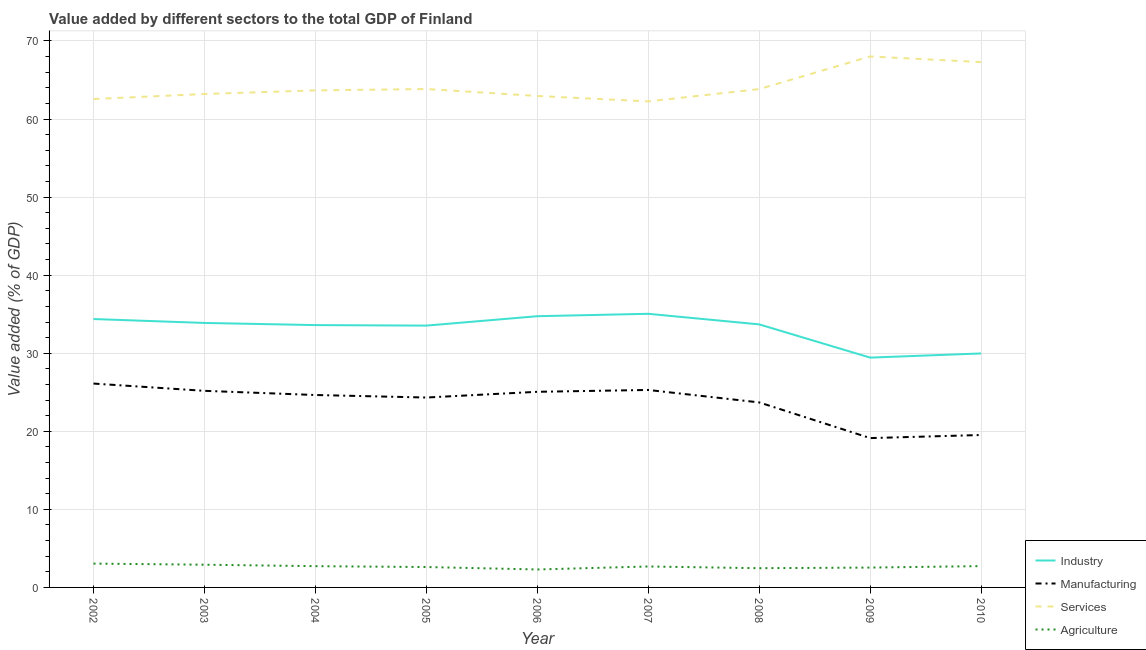How many different coloured lines are there?
Provide a succinct answer. 4. Is the number of lines equal to the number of legend labels?
Provide a short and direct response. Yes. What is the value added by industrial sector in 2004?
Offer a very short reply. 33.61. Across all years, what is the maximum value added by services sector?
Ensure brevity in your answer.  68.02. Across all years, what is the minimum value added by agricultural sector?
Offer a terse response. 2.3. In which year was the value added by manufacturing sector minimum?
Ensure brevity in your answer.  2009. What is the total value added by services sector in the graph?
Your answer should be compact. 577.67. What is the difference between the value added by agricultural sector in 2002 and that in 2010?
Your answer should be very brief. 0.32. What is the difference between the value added by services sector in 2006 and the value added by agricultural sector in 2003?
Ensure brevity in your answer.  60.05. What is the average value added by manufacturing sector per year?
Keep it short and to the point. 23.67. In the year 2006, what is the difference between the value added by services sector and value added by agricultural sector?
Offer a very short reply. 60.66. What is the ratio of the value added by services sector in 2005 to that in 2008?
Provide a short and direct response. 1. Is the value added by agricultural sector in 2005 less than that in 2006?
Your answer should be compact. No. What is the difference between the highest and the second highest value added by agricultural sector?
Offer a very short reply. 0.14. What is the difference between the highest and the lowest value added by industrial sector?
Keep it short and to the point. 5.61. In how many years, is the value added by industrial sector greater than the average value added by industrial sector taken over all years?
Offer a terse response. 7. Does the value added by agricultural sector monotonically increase over the years?
Offer a terse response. No. Is the value added by manufacturing sector strictly less than the value added by industrial sector over the years?
Ensure brevity in your answer.  Yes. How many lines are there?
Keep it short and to the point. 4. Does the graph contain any zero values?
Make the answer very short. No. Does the graph contain grids?
Make the answer very short. Yes. Where does the legend appear in the graph?
Your response must be concise. Bottom right. How many legend labels are there?
Your answer should be very brief. 4. What is the title of the graph?
Your answer should be very brief. Value added by different sectors to the total GDP of Finland. Does "Primary schools" appear as one of the legend labels in the graph?
Provide a short and direct response. No. What is the label or title of the Y-axis?
Your response must be concise. Value added (% of GDP). What is the Value added (% of GDP) of Industry in 2002?
Make the answer very short. 34.38. What is the Value added (% of GDP) of Manufacturing in 2002?
Ensure brevity in your answer.  26.12. What is the Value added (% of GDP) in Services in 2002?
Offer a very short reply. 62.57. What is the Value added (% of GDP) in Agriculture in 2002?
Ensure brevity in your answer.  3.05. What is the Value added (% of GDP) of Industry in 2003?
Make the answer very short. 33.88. What is the Value added (% of GDP) in Manufacturing in 2003?
Provide a succinct answer. 25.18. What is the Value added (% of GDP) in Services in 2003?
Provide a succinct answer. 63.21. What is the Value added (% of GDP) of Agriculture in 2003?
Give a very brief answer. 2.91. What is the Value added (% of GDP) in Industry in 2004?
Make the answer very short. 33.61. What is the Value added (% of GDP) in Manufacturing in 2004?
Make the answer very short. 24.65. What is the Value added (% of GDP) in Services in 2004?
Make the answer very short. 63.67. What is the Value added (% of GDP) in Agriculture in 2004?
Ensure brevity in your answer.  2.72. What is the Value added (% of GDP) of Industry in 2005?
Give a very brief answer. 33.54. What is the Value added (% of GDP) in Manufacturing in 2005?
Make the answer very short. 24.33. What is the Value added (% of GDP) of Services in 2005?
Keep it short and to the point. 63.85. What is the Value added (% of GDP) in Agriculture in 2005?
Your answer should be compact. 2.61. What is the Value added (% of GDP) of Industry in 2006?
Ensure brevity in your answer.  34.74. What is the Value added (% of GDP) of Manufacturing in 2006?
Provide a succinct answer. 25.06. What is the Value added (% of GDP) in Services in 2006?
Offer a terse response. 62.96. What is the Value added (% of GDP) of Agriculture in 2006?
Offer a very short reply. 2.3. What is the Value added (% of GDP) of Industry in 2007?
Ensure brevity in your answer.  35.05. What is the Value added (% of GDP) of Manufacturing in 2007?
Make the answer very short. 25.3. What is the Value added (% of GDP) of Services in 2007?
Your response must be concise. 62.26. What is the Value added (% of GDP) in Agriculture in 2007?
Ensure brevity in your answer.  2.68. What is the Value added (% of GDP) of Industry in 2008?
Offer a very short reply. 33.7. What is the Value added (% of GDP) in Manufacturing in 2008?
Your answer should be very brief. 23.7. What is the Value added (% of GDP) in Services in 2008?
Your answer should be very brief. 63.84. What is the Value added (% of GDP) in Agriculture in 2008?
Offer a terse response. 2.46. What is the Value added (% of GDP) of Industry in 2009?
Make the answer very short. 29.44. What is the Value added (% of GDP) in Manufacturing in 2009?
Give a very brief answer. 19.13. What is the Value added (% of GDP) in Services in 2009?
Your answer should be very brief. 68.02. What is the Value added (% of GDP) in Agriculture in 2009?
Make the answer very short. 2.54. What is the Value added (% of GDP) of Industry in 2010?
Keep it short and to the point. 29.97. What is the Value added (% of GDP) of Manufacturing in 2010?
Provide a short and direct response. 19.53. What is the Value added (% of GDP) in Services in 2010?
Keep it short and to the point. 67.3. What is the Value added (% of GDP) of Agriculture in 2010?
Your response must be concise. 2.73. Across all years, what is the maximum Value added (% of GDP) of Industry?
Keep it short and to the point. 35.05. Across all years, what is the maximum Value added (% of GDP) of Manufacturing?
Make the answer very short. 26.12. Across all years, what is the maximum Value added (% of GDP) of Services?
Keep it short and to the point. 68.02. Across all years, what is the maximum Value added (% of GDP) in Agriculture?
Your answer should be compact. 3.05. Across all years, what is the minimum Value added (% of GDP) of Industry?
Your response must be concise. 29.44. Across all years, what is the minimum Value added (% of GDP) of Manufacturing?
Ensure brevity in your answer.  19.13. Across all years, what is the minimum Value added (% of GDP) of Services?
Provide a short and direct response. 62.26. Across all years, what is the minimum Value added (% of GDP) in Agriculture?
Provide a short and direct response. 2.3. What is the total Value added (% of GDP) of Industry in the graph?
Provide a short and direct response. 298.32. What is the total Value added (% of GDP) in Manufacturing in the graph?
Your answer should be very brief. 212.99. What is the total Value added (% of GDP) in Services in the graph?
Provide a short and direct response. 577.67. What is the total Value added (% of GDP) in Agriculture in the graph?
Provide a short and direct response. 24.02. What is the difference between the Value added (% of GDP) in Industry in 2002 and that in 2003?
Provide a succinct answer. 0.5. What is the difference between the Value added (% of GDP) in Manufacturing in 2002 and that in 2003?
Provide a short and direct response. 0.93. What is the difference between the Value added (% of GDP) of Services in 2002 and that in 2003?
Give a very brief answer. -0.64. What is the difference between the Value added (% of GDP) of Agriculture in 2002 and that in 2003?
Keep it short and to the point. 0.14. What is the difference between the Value added (% of GDP) in Industry in 2002 and that in 2004?
Give a very brief answer. 0.78. What is the difference between the Value added (% of GDP) in Manufacturing in 2002 and that in 2004?
Give a very brief answer. 1.47. What is the difference between the Value added (% of GDP) in Services in 2002 and that in 2004?
Provide a short and direct response. -1.11. What is the difference between the Value added (% of GDP) in Agriculture in 2002 and that in 2004?
Offer a very short reply. 0.33. What is the difference between the Value added (% of GDP) in Industry in 2002 and that in 2005?
Your response must be concise. 0.84. What is the difference between the Value added (% of GDP) in Manufacturing in 2002 and that in 2005?
Your answer should be compact. 1.79. What is the difference between the Value added (% of GDP) in Services in 2002 and that in 2005?
Offer a very short reply. -1.28. What is the difference between the Value added (% of GDP) in Agriculture in 2002 and that in 2005?
Make the answer very short. 0.44. What is the difference between the Value added (% of GDP) in Industry in 2002 and that in 2006?
Your answer should be compact. -0.36. What is the difference between the Value added (% of GDP) of Manufacturing in 2002 and that in 2006?
Give a very brief answer. 1.05. What is the difference between the Value added (% of GDP) in Services in 2002 and that in 2006?
Provide a short and direct response. -0.39. What is the difference between the Value added (% of GDP) of Agriculture in 2002 and that in 2006?
Your answer should be very brief. 0.75. What is the difference between the Value added (% of GDP) of Industry in 2002 and that in 2007?
Make the answer very short. -0.67. What is the difference between the Value added (% of GDP) of Manufacturing in 2002 and that in 2007?
Provide a succinct answer. 0.82. What is the difference between the Value added (% of GDP) of Services in 2002 and that in 2007?
Your response must be concise. 0.3. What is the difference between the Value added (% of GDP) in Agriculture in 2002 and that in 2007?
Ensure brevity in your answer.  0.37. What is the difference between the Value added (% of GDP) in Industry in 2002 and that in 2008?
Give a very brief answer. 0.69. What is the difference between the Value added (% of GDP) of Manufacturing in 2002 and that in 2008?
Provide a succinct answer. 2.41. What is the difference between the Value added (% of GDP) in Services in 2002 and that in 2008?
Your answer should be compact. -1.28. What is the difference between the Value added (% of GDP) in Agriculture in 2002 and that in 2008?
Offer a terse response. 0.59. What is the difference between the Value added (% of GDP) in Industry in 2002 and that in 2009?
Ensure brevity in your answer.  4.94. What is the difference between the Value added (% of GDP) of Manufacturing in 2002 and that in 2009?
Your response must be concise. 6.99. What is the difference between the Value added (% of GDP) of Services in 2002 and that in 2009?
Offer a terse response. -5.45. What is the difference between the Value added (% of GDP) of Agriculture in 2002 and that in 2009?
Provide a succinct answer. 0.51. What is the difference between the Value added (% of GDP) in Industry in 2002 and that in 2010?
Make the answer very short. 4.41. What is the difference between the Value added (% of GDP) in Manufacturing in 2002 and that in 2010?
Make the answer very short. 6.59. What is the difference between the Value added (% of GDP) in Services in 2002 and that in 2010?
Your response must be concise. -4.73. What is the difference between the Value added (% of GDP) in Agriculture in 2002 and that in 2010?
Your response must be concise. 0.32. What is the difference between the Value added (% of GDP) of Industry in 2003 and that in 2004?
Provide a short and direct response. 0.28. What is the difference between the Value added (% of GDP) of Manufacturing in 2003 and that in 2004?
Keep it short and to the point. 0.54. What is the difference between the Value added (% of GDP) in Services in 2003 and that in 2004?
Your answer should be very brief. -0.46. What is the difference between the Value added (% of GDP) of Agriculture in 2003 and that in 2004?
Your answer should be very brief. 0.19. What is the difference between the Value added (% of GDP) in Industry in 2003 and that in 2005?
Your response must be concise. 0.34. What is the difference between the Value added (% of GDP) of Manufacturing in 2003 and that in 2005?
Your response must be concise. 0.86. What is the difference between the Value added (% of GDP) of Services in 2003 and that in 2005?
Your response must be concise. -0.64. What is the difference between the Value added (% of GDP) of Agriculture in 2003 and that in 2005?
Your response must be concise. 0.3. What is the difference between the Value added (% of GDP) in Industry in 2003 and that in 2006?
Provide a succinct answer. -0.86. What is the difference between the Value added (% of GDP) in Manufacturing in 2003 and that in 2006?
Ensure brevity in your answer.  0.12. What is the difference between the Value added (% of GDP) of Services in 2003 and that in 2006?
Offer a terse response. 0.25. What is the difference between the Value added (% of GDP) in Agriculture in 2003 and that in 2006?
Offer a terse response. 0.61. What is the difference between the Value added (% of GDP) of Industry in 2003 and that in 2007?
Offer a very short reply. -1.17. What is the difference between the Value added (% of GDP) of Manufacturing in 2003 and that in 2007?
Provide a short and direct response. -0.11. What is the difference between the Value added (% of GDP) in Services in 2003 and that in 2007?
Give a very brief answer. 0.94. What is the difference between the Value added (% of GDP) in Agriculture in 2003 and that in 2007?
Keep it short and to the point. 0.23. What is the difference between the Value added (% of GDP) in Industry in 2003 and that in 2008?
Provide a short and direct response. 0.19. What is the difference between the Value added (% of GDP) of Manufacturing in 2003 and that in 2008?
Keep it short and to the point. 1.48. What is the difference between the Value added (% of GDP) in Services in 2003 and that in 2008?
Your answer should be very brief. -0.63. What is the difference between the Value added (% of GDP) in Agriculture in 2003 and that in 2008?
Offer a very short reply. 0.45. What is the difference between the Value added (% of GDP) of Industry in 2003 and that in 2009?
Keep it short and to the point. 4.44. What is the difference between the Value added (% of GDP) in Manufacturing in 2003 and that in 2009?
Offer a terse response. 6.05. What is the difference between the Value added (% of GDP) of Services in 2003 and that in 2009?
Provide a short and direct response. -4.81. What is the difference between the Value added (% of GDP) in Agriculture in 2003 and that in 2009?
Your answer should be compact. 0.37. What is the difference between the Value added (% of GDP) of Industry in 2003 and that in 2010?
Keep it short and to the point. 3.91. What is the difference between the Value added (% of GDP) in Manufacturing in 2003 and that in 2010?
Offer a terse response. 5.66. What is the difference between the Value added (% of GDP) in Services in 2003 and that in 2010?
Ensure brevity in your answer.  -4.09. What is the difference between the Value added (% of GDP) in Agriculture in 2003 and that in 2010?
Give a very brief answer. 0.18. What is the difference between the Value added (% of GDP) of Industry in 2004 and that in 2005?
Offer a very short reply. 0.07. What is the difference between the Value added (% of GDP) of Manufacturing in 2004 and that in 2005?
Make the answer very short. 0.32. What is the difference between the Value added (% of GDP) of Services in 2004 and that in 2005?
Ensure brevity in your answer.  -0.18. What is the difference between the Value added (% of GDP) in Agriculture in 2004 and that in 2005?
Your response must be concise. 0.11. What is the difference between the Value added (% of GDP) in Industry in 2004 and that in 2006?
Ensure brevity in your answer.  -1.14. What is the difference between the Value added (% of GDP) in Manufacturing in 2004 and that in 2006?
Your answer should be compact. -0.41. What is the difference between the Value added (% of GDP) of Services in 2004 and that in 2006?
Keep it short and to the point. 0.72. What is the difference between the Value added (% of GDP) of Agriculture in 2004 and that in 2006?
Offer a terse response. 0.42. What is the difference between the Value added (% of GDP) in Industry in 2004 and that in 2007?
Provide a short and direct response. -1.45. What is the difference between the Value added (% of GDP) of Manufacturing in 2004 and that in 2007?
Give a very brief answer. -0.65. What is the difference between the Value added (% of GDP) of Services in 2004 and that in 2007?
Give a very brief answer. 1.41. What is the difference between the Value added (% of GDP) in Agriculture in 2004 and that in 2007?
Give a very brief answer. 0.04. What is the difference between the Value added (% of GDP) of Industry in 2004 and that in 2008?
Make the answer very short. -0.09. What is the difference between the Value added (% of GDP) in Manufacturing in 2004 and that in 2008?
Give a very brief answer. 0.95. What is the difference between the Value added (% of GDP) of Services in 2004 and that in 2008?
Your response must be concise. -0.17. What is the difference between the Value added (% of GDP) of Agriculture in 2004 and that in 2008?
Offer a terse response. 0.26. What is the difference between the Value added (% of GDP) in Industry in 2004 and that in 2009?
Offer a very short reply. 4.17. What is the difference between the Value added (% of GDP) in Manufacturing in 2004 and that in 2009?
Your answer should be very brief. 5.52. What is the difference between the Value added (% of GDP) in Services in 2004 and that in 2009?
Your answer should be very brief. -4.35. What is the difference between the Value added (% of GDP) of Agriculture in 2004 and that in 2009?
Offer a terse response. 0.18. What is the difference between the Value added (% of GDP) in Industry in 2004 and that in 2010?
Keep it short and to the point. 3.63. What is the difference between the Value added (% of GDP) in Manufacturing in 2004 and that in 2010?
Offer a terse response. 5.12. What is the difference between the Value added (% of GDP) of Services in 2004 and that in 2010?
Your response must be concise. -3.62. What is the difference between the Value added (% of GDP) in Agriculture in 2004 and that in 2010?
Make the answer very short. -0.01. What is the difference between the Value added (% of GDP) in Industry in 2005 and that in 2006?
Your answer should be compact. -1.21. What is the difference between the Value added (% of GDP) of Manufacturing in 2005 and that in 2006?
Your answer should be very brief. -0.73. What is the difference between the Value added (% of GDP) of Services in 2005 and that in 2006?
Provide a short and direct response. 0.89. What is the difference between the Value added (% of GDP) in Agriculture in 2005 and that in 2006?
Your response must be concise. 0.31. What is the difference between the Value added (% of GDP) in Industry in 2005 and that in 2007?
Your response must be concise. -1.51. What is the difference between the Value added (% of GDP) in Manufacturing in 2005 and that in 2007?
Make the answer very short. -0.97. What is the difference between the Value added (% of GDP) in Services in 2005 and that in 2007?
Provide a succinct answer. 1.58. What is the difference between the Value added (% of GDP) in Agriculture in 2005 and that in 2007?
Offer a terse response. -0.07. What is the difference between the Value added (% of GDP) in Industry in 2005 and that in 2008?
Your response must be concise. -0.16. What is the difference between the Value added (% of GDP) of Manufacturing in 2005 and that in 2008?
Make the answer very short. 0.63. What is the difference between the Value added (% of GDP) of Services in 2005 and that in 2008?
Provide a short and direct response. 0.01. What is the difference between the Value added (% of GDP) in Agriculture in 2005 and that in 2008?
Provide a succinct answer. 0.15. What is the difference between the Value added (% of GDP) of Industry in 2005 and that in 2009?
Provide a short and direct response. 4.1. What is the difference between the Value added (% of GDP) of Manufacturing in 2005 and that in 2009?
Ensure brevity in your answer.  5.2. What is the difference between the Value added (% of GDP) in Services in 2005 and that in 2009?
Offer a very short reply. -4.17. What is the difference between the Value added (% of GDP) of Agriculture in 2005 and that in 2009?
Keep it short and to the point. 0.07. What is the difference between the Value added (% of GDP) of Industry in 2005 and that in 2010?
Your response must be concise. 3.57. What is the difference between the Value added (% of GDP) in Manufacturing in 2005 and that in 2010?
Offer a very short reply. 4.8. What is the difference between the Value added (% of GDP) in Services in 2005 and that in 2010?
Offer a terse response. -3.45. What is the difference between the Value added (% of GDP) in Agriculture in 2005 and that in 2010?
Provide a succinct answer. -0.12. What is the difference between the Value added (% of GDP) of Industry in 2006 and that in 2007?
Provide a succinct answer. -0.31. What is the difference between the Value added (% of GDP) in Manufacturing in 2006 and that in 2007?
Offer a terse response. -0.24. What is the difference between the Value added (% of GDP) in Services in 2006 and that in 2007?
Give a very brief answer. 0.69. What is the difference between the Value added (% of GDP) in Agriculture in 2006 and that in 2007?
Provide a short and direct response. -0.38. What is the difference between the Value added (% of GDP) in Industry in 2006 and that in 2008?
Offer a terse response. 1.05. What is the difference between the Value added (% of GDP) in Manufacturing in 2006 and that in 2008?
Offer a very short reply. 1.36. What is the difference between the Value added (% of GDP) of Services in 2006 and that in 2008?
Offer a terse response. -0.88. What is the difference between the Value added (% of GDP) in Agriculture in 2006 and that in 2008?
Keep it short and to the point. -0.16. What is the difference between the Value added (% of GDP) of Industry in 2006 and that in 2009?
Ensure brevity in your answer.  5.31. What is the difference between the Value added (% of GDP) of Manufacturing in 2006 and that in 2009?
Ensure brevity in your answer.  5.93. What is the difference between the Value added (% of GDP) of Services in 2006 and that in 2009?
Offer a terse response. -5.06. What is the difference between the Value added (% of GDP) of Agriculture in 2006 and that in 2009?
Make the answer very short. -0.24. What is the difference between the Value added (% of GDP) of Industry in 2006 and that in 2010?
Make the answer very short. 4.77. What is the difference between the Value added (% of GDP) of Manufacturing in 2006 and that in 2010?
Give a very brief answer. 5.53. What is the difference between the Value added (% of GDP) in Services in 2006 and that in 2010?
Give a very brief answer. -4.34. What is the difference between the Value added (% of GDP) of Agriculture in 2006 and that in 2010?
Offer a terse response. -0.43. What is the difference between the Value added (% of GDP) of Industry in 2007 and that in 2008?
Provide a short and direct response. 1.36. What is the difference between the Value added (% of GDP) of Manufacturing in 2007 and that in 2008?
Offer a very short reply. 1.59. What is the difference between the Value added (% of GDP) of Services in 2007 and that in 2008?
Ensure brevity in your answer.  -1.58. What is the difference between the Value added (% of GDP) in Agriculture in 2007 and that in 2008?
Your response must be concise. 0.22. What is the difference between the Value added (% of GDP) of Industry in 2007 and that in 2009?
Provide a short and direct response. 5.61. What is the difference between the Value added (% of GDP) in Manufacturing in 2007 and that in 2009?
Give a very brief answer. 6.17. What is the difference between the Value added (% of GDP) in Services in 2007 and that in 2009?
Your answer should be very brief. -5.75. What is the difference between the Value added (% of GDP) of Agriculture in 2007 and that in 2009?
Provide a short and direct response. 0.14. What is the difference between the Value added (% of GDP) in Industry in 2007 and that in 2010?
Your answer should be compact. 5.08. What is the difference between the Value added (% of GDP) in Manufacturing in 2007 and that in 2010?
Provide a succinct answer. 5.77. What is the difference between the Value added (% of GDP) in Services in 2007 and that in 2010?
Make the answer very short. -5.03. What is the difference between the Value added (% of GDP) of Agriculture in 2007 and that in 2010?
Your answer should be compact. -0.05. What is the difference between the Value added (% of GDP) of Industry in 2008 and that in 2009?
Your response must be concise. 4.26. What is the difference between the Value added (% of GDP) in Manufacturing in 2008 and that in 2009?
Your answer should be very brief. 4.57. What is the difference between the Value added (% of GDP) in Services in 2008 and that in 2009?
Make the answer very short. -4.18. What is the difference between the Value added (% of GDP) of Agriculture in 2008 and that in 2009?
Offer a very short reply. -0.08. What is the difference between the Value added (% of GDP) in Industry in 2008 and that in 2010?
Offer a very short reply. 3.72. What is the difference between the Value added (% of GDP) of Manufacturing in 2008 and that in 2010?
Provide a short and direct response. 4.18. What is the difference between the Value added (% of GDP) in Services in 2008 and that in 2010?
Ensure brevity in your answer.  -3.46. What is the difference between the Value added (% of GDP) of Agriculture in 2008 and that in 2010?
Your answer should be very brief. -0.27. What is the difference between the Value added (% of GDP) in Industry in 2009 and that in 2010?
Your answer should be very brief. -0.53. What is the difference between the Value added (% of GDP) of Manufacturing in 2009 and that in 2010?
Give a very brief answer. -0.4. What is the difference between the Value added (% of GDP) in Services in 2009 and that in 2010?
Give a very brief answer. 0.72. What is the difference between the Value added (% of GDP) of Agriculture in 2009 and that in 2010?
Ensure brevity in your answer.  -0.19. What is the difference between the Value added (% of GDP) in Industry in 2002 and the Value added (% of GDP) in Manufacturing in 2003?
Make the answer very short. 9.2. What is the difference between the Value added (% of GDP) in Industry in 2002 and the Value added (% of GDP) in Services in 2003?
Make the answer very short. -28.83. What is the difference between the Value added (% of GDP) of Industry in 2002 and the Value added (% of GDP) of Agriculture in 2003?
Offer a terse response. 31.47. What is the difference between the Value added (% of GDP) of Manufacturing in 2002 and the Value added (% of GDP) of Services in 2003?
Keep it short and to the point. -37.09. What is the difference between the Value added (% of GDP) of Manufacturing in 2002 and the Value added (% of GDP) of Agriculture in 2003?
Keep it short and to the point. 23.21. What is the difference between the Value added (% of GDP) in Services in 2002 and the Value added (% of GDP) in Agriculture in 2003?
Offer a terse response. 59.66. What is the difference between the Value added (% of GDP) of Industry in 2002 and the Value added (% of GDP) of Manufacturing in 2004?
Offer a very short reply. 9.73. What is the difference between the Value added (% of GDP) in Industry in 2002 and the Value added (% of GDP) in Services in 2004?
Provide a short and direct response. -29.29. What is the difference between the Value added (% of GDP) in Industry in 2002 and the Value added (% of GDP) in Agriculture in 2004?
Ensure brevity in your answer.  31.66. What is the difference between the Value added (% of GDP) of Manufacturing in 2002 and the Value added (% of GDP) of Services in 2004?
Make the answer very short. -37.56. What is the difference between the Value added (% of GDP) of Manufacturing in 2002 and the Value added (% of GDP) of Agriculture in 2004?
Your answer should be very brief. 23.39. What is the difference between the Value added (% of GDP) in Services in 2002 and the Value added (% of GDP) in Agriculture in 2004?
Provide a short and direct response. 59.84. What is the difference between the Value added (% of GDP) in Industry in 2002 and the Value added (% of GDP) in Manufacturing in 2005?
Ensure brevity in your answer.  10.06. What is the difference between the Value added (% of GDP) in Industry in 2002 and the Value added (% of GDP) in Services in 2005?
Your response must be concise. -29.46. What is the difference between the Value added (% of GDP) of Industry in 2002 and the Value added (% of GDP) of Agriculture in 2005?
Your answer should be compact. 31.77. What is the difference between the Value added (% of GDP) of Manufacturing in 2002 and the Value added (% of GDP) of Services in 2005?
Offer a terse response. -37.73. What is the difference between the Value added (% of GDP) of Manufacturing in 2002 and the Value added (% of GDP) of Agriculture in 2005?
Your response must be concise. 23.5. What is the difference between the Value added (% of GDP) in Services in 2002 and the Value added (% of GDP) in Agriculture in 2005?
Give a very brief answer. 59.95. What is the difference between the Value added (% of GDP) in Industry in 2002 and the Value added (% of GDP) in Manufacturing in 2006?
Provide a short and direct response. 9.32. What is the difference between the Value added (% of GDP) in Industry in 2002 and the Value added (% of GDP) in Services in 2006?
Ensure brevity in your answer.  -28.57. What is the difference between the Value added (% of GDP) of Industry in 2002 and the Value added (% of GDP) of Agriculture in 2006?
Make the answer very short. 32.08. What is the difference between the Value added (% of GDP) of Manufacturing in 2002 and the Value added (% of GDP) of Services in 2006?
Provide a short and direct response. -36.84. What is the difference between the Value added (% of GDP) of Manufacturing in 2002 and the Value added (% of GDP) of Agriculture in 2006?
Give a very brief answer. 23.82. What is the difference between the Value added (% of GDP) of Services in 2002 and the Value added (% of GDP) of Agriculture in 2006?
Your response must be concise. 60.27. What is the difference between the Value added (% of GDP) in Industry in 2002 and the Value added (% of GDP) in Manufacturing in 2007?
Make the answer very short. 9.09. What is the difference between the Value added (% of GDP) in Industry in 2002 and the Value added (% of GDP) in Services in 2007?
Offer a terse response. -27.88. What is the difference between the Value added (% of GDP) of Industry in 2002 and the Value added (% of GDP) of Agriculture in 2007?
Ensure brevity in your answer.  31.7. What is the difference between the Value added (% of GDP) in Manufacturing in 2002 and the Value added (% of GDP) in Services in 2007?
Give a very brief answer. -36.15. What is the difference between the Value added (% of GDP) in Manufacturing in 2002 and the Value added (% of GDP) in Agriculture in 2007?
Ensure brevity in your answer.  23.43. What is the difference between the Value added (% of GDP) in Services in 2002 and the Value added (% of GDP) in Agriculture in 2007?
Make the answer very short. 59.88. What is the difference between the Value added (% of GDP) in Industry in 2002 and the Value added (% of GDP) in Manufacturing in 2008?
Keep it short and to the point. 10.68. What is the difference between the Value added (% of GDP) in Industry in 2002 and the Value added (% of GDP) in Services in 2008?
Your answer should be very brief. -29.46. What is the difference between the Value added (% of GDP) of Industry in 2002 and the Value added (% of GDP) of Agriculture in 2008?
Offer a very short reply. 31.92. What is the difference between the Value added (% of GDP) of Manufacturing in 2002 and the Value added (% of GDP) of Services in 2008?
Your answer should be very brief. -37.73. What is the difference between the Value added (% of GDP) in Manufacturing in 2002 and the Value added (% of GDP) in Agriculture in 2008?
Make the answer very short. 23.65. What is the difference between the Value added (% of GDP) of Services in 2002 and the Value added (% of GDP) of Agriculture in 2008?
Provide a short and direct response. 60.1. What is the difference between the Value added (% of GDP) of Industry in 2002 and the Value added (% of GDP) of Manufacturing in 2009?
Your response must be concise. 15.25. What is the difference between the Value added (% of GDP) of Industry in 2002 and the Value added (% of GDP) of Services in 2009?
Provide a short and direct response. -33.63. What is the difference between the Value added (% of GDP) of Industry in 2002 and the Value added (% of GDP) of Agriculture in 2009?
Offer a very short reply. 31.84. What is the difference between the Value added (% of GDP) in Manufacturing in 2002 and the Value added (% of GDP) in Services in 2009?
Your answer should be compact. -41.9. What is the difference between the Value added (% of GDP) in Manufacturing in 2002 and the Value added (% of GDP) in Agriculture in 2009?
Your answer should be very brief. 23.57. What is the difference between the Value added (% of GDP) in Services in 2002 and the Value added (% of GDP) in Agriculture in 2009?
Offer a terse response. 60.02. What is the difference between the Value added (% of GDP) of Industry in 2002 and the Value added (% of GDP) of Manufacturing in 2010?
Offer a very short reply. 14.86. What is the difference between the Value added (% of GDP) in Industry in 2002 and the Value added (% of GDP) in Services in 2010?
Your response must be concise. -32.91. What is the difference between the Value added (% of GDP) of Industry in 2002 and the Value added (% of GDP) of Agriculture in 2010?
Your response must be concise. 31.65. What is the difference between the Value added (% of GDP) of Manufacturing in 2002 and the Value added (% of GDP) of Services in 2010?
Your response must be concise. -41.18. What is the difference between the Value added (% of GDP) in Manufacturing in 2002 and the Value added (% of GDP) in Agriculture in 2010?
Provide a short and direct response. 23.38. What is the difference between the Value added (% of GDP) of Services in 2002 and the Value added (% of GDP) of Agriculture in 2010?
Your response must be concise. 59.83. What is the difference between the Value added (% of GDP) in Industry in 2003 and the Value added (% of GDP) in Manufacturing in 2004?
Your response must be concise. 9.23. What is the difference between the Value added (% of GDP) in Industry in 2003 and the Value added (% of GDP) in Services in 2004?
Make the answer very short. -29.79. What is the difference between the Value added (% of GDP) in Industry in 2003 and the Value added (% of GDP) in Agriculture in 2004?
Offer a very short reply. 31.16. What is the difference between the Value added (% of GDP) of Manufacturing in 2003 and the Value added (% of GDP) of Services in 2004?
Your answer should be compact. -38.49. What is the difference between the Value added (% of GDP) in Manufacturing in 2003 and the Value added (% of GDP) in Agriculture in 2004?
Offer a terse response. 22.46. What is the difference between the Value added (% of GDP) in Services in 2003 and the Value added (% of GDP) in Agriculture in 2004?
Make the answer very short. 60.49. What is the difference between the Value added (% of GDP) in Industry in 2003 and the Value added (% of GDP) in Manufacturing in 2005?
Ensure brevity in your answer.  9.55. What is the difference between the Value added (% of GDP) in Industry in 2003 and the Value added (% of GDP) in Services in 2005?
Ensure brevity in your answer.  -29.97. What is the difference between the Value added (% of GDP) of Industry in 2003 and the Value added (% of GDP) of Agriculture in 2005?
Offer a terse response. 31.27. What is the difference between the Value added (% of GDP) in Manufacturing in 2003 and the Value added (% of GDP) in Services in 2005?
Give a very brief answer. -38.66. What is the difference between the Value added (% of GDP) of Manufacturing in 2003 and the Value added (% of GDP) of Agriculture in 2005?
Your answer should be compact. 22.57. What is the difference between the Value added (% of GDP) in Services in 2003 and the Value added (% of GDP) in Agriculture in 2005?
Offer a very short reply. 60.6. What is the difference between the Value added (% of GDP) of Industry in 2003 and the Value added (% of GDP) of Manufacturing in 2006?
Offer a terse response. 8.82. What is the difference between the Value added (% of GDP) in Industry in 2003 and the Value added (% of GDP) in Services in 2006?
Make the answer very short. -29.07. What is the difference between the Value added (% of GDP) in Industry in 2003 and the Value added (% of GDP) in Agriculture in 2006?
Make the answer very short. 31.58. What is the difference between the Value added (% of GDP) of Manufacturing in 2003 and the Value added (% of GDP) of Services in 2006?
Offer a very short reply. -37.77. What is the difference between the Value added (% of GDP) in Manufacturing in 2003 and the Value added (% of GDP) in Agriculture in 2006?
Give a very brief answer. 22.89. What is the difference between the Value added (% of GDP) of Services in 2003 and the Value added (% of GDP) of Agriculture in 2006?
Provide a succinct answer. 60.91. What is the difference between the Value added (% of GDP) of Industry in 2003 and the Value added (% of GDP) of Manufacturing in 2007?
Ensure brevity in your answer.  8.59. What is the difference between the Value added (% of GDP) in Industry in 2003 and the Value added (% of GDP) in Services in 2007?
Offer a terse response. -28.38. What is the difference between the Value added (% of GDP) of Industry in 2003 and the Value added (% of GDP) of Agriculture in 2007?
Keep it short and to the point. 31.2. What is the difference between the Value added (% of GDP) in Manufacturing in 2003 and the Value added (% of GDP) in Services in 2007?
Offer a very short reply. -37.08. What is the difference between the Value added (% of GDP) in Manufacturing in 2003 and the Value added (% of GDP) in Agriculture in 2007?
Give a very brief answer. 22.5. What is the difference between the Value added (% of GDP) of Services in 2003 and the Value added (% of GDP) of Agriculture in 2007?
Your answer should be compact. 60.53. What is the difference between the Value added (% of GDP) in Industry in 2003 and the Value added (% of GDP) in Manufacturing in 2008?
Offer a very short reply. 10.18. What is the difference between the Value added (% of GDP) of Industry in 2003 and the Value added (% of GDP) of Services in 2008?
Your answer should be very brief. -29.96. What is the difference between the Value added (% of GDP) in Industry in 2003 and the Value added (% of GDP) in Agriculture in 2008?
Provide a short and direct response. 31.42. What is the difference between the Value added (% of GDP) in Manufacturing in 2003 and the Value added (% of GDP) in Services in 2008?
Make the answer very short. -38.66. What is the difference between the Value added (% of GDP) in Manufacturing in 2003 and the Value added (% of GDP) in Agriculture in 2008?
Your answer should be very brief. 22.72. What is the difference between the Value added (% of GDP) of Services in 2003 and the Value added (% of GDP) of Agriculture in 2008?
Provide a succinct answer. 60.74. What is the difference between the Value added (% of GDP) of Industry in 2003 and the Value added (% of GDP) of Manufacturing in 2009?
Your answer should be very brief. 14.75. What is the difference between the Value added (% of GDP) in Industry in 2003 and the Value added (% of GDP) in Services in 2009?
Offer a terse response. -34.14. What is the difference between the Value added (% of GDP) in Industry in 2003 and the Value added (% of GDP) in Agriculture in 2009?
Provide a succinct answer. 31.34. What is the difference between the Value added (% of GDP) in Manufacturing in 2003 and the Value added (% of GDP) in Services in 2009?
Keep it short and to the point. -42.83. What is the difference between the Value added (% of GDP) in Manufacturing in 2003 and the Value added (% of GDP) in Agriculture in 2009?
Offer a very short reply. 22.64. What is the difference between the Value added (% of GDP) of Services in 2003 and the Value added (% of GDP) of Agriculture in 2009?
Provide a short and direct response. 60.66. What is the difference between the Value added (% of GDP) in Industry in 2003 and the Value added (% of GDP) in Manufacturing in 2010?
Ensure brevity in your answer.  14.36. What is the difference between the Value added (% of GDP) of Industry in 2003 and the Value added (% of GDP) of Services in 2010?
Your response must be concise. -33.41. What is the difference between the Value added (% of GDP) of Industry in 2003 and the Value added (% of GDP) of Agriculture in 2010?
Your answer should be compact. 31.15. What is the difference between the Value added (% of GDP) of Manufacturing in 2003 and the Value added (% of GDP) of Services in 2010?
Keep it short and to the point. -42.11. What is the difference between the Value added (% of GDP) in Manufacturing in 2003 and the Value added (% of GDP) in Agriculture in 2010?
Your answer should be compact. 22.45. What is the difference between the Value added (% of GDP) in Services in 2003 and the Value added (% of GDP) in Agriculture in 2010?
Your answer should be very brief. 60.48. What is the difference between the Value added (% of GDP) of Industry in 2004 and the Value added (% of GDP) of Manufacturing in 2005?
Make the answer very short. 9.28. What is the difference between the Value added (% of GDP) in Industry in 2004 and the Value added (% of GDP) in Services in 2005?
Your answer should be compact. -30.24. What is the difference between the Value added (% of GDP) of Industry in 2004 and the Value added (% of GDP) of Agriculture in 2005?
Make the answer very short. 30.99. What is the difference between the Value added (% of GDP) of Manufacturing in 2004 and the Value added (% of GDP) of Services in 2005?
Provide a short and direct response. -39.2. What is the difference between the Value added (% of GDP) in Manufacturing in 2004 and the Value added (% of GDP) in Agriculture in 2005?
Ensure brevity in your answer.  22.04. What is the difference between the Value added (% of GDP) of Services in 2004 and the Value added (% of GDP) of Agriculture in 2005?
Provide a succinct answer. 61.06. What is the difference between the Value added (% of GDP) of Industry in 2004 and the Value added (% of GDP) of Manufacturing in 2006?
Your answer should be very brief. 8.55. What is the difference between the Value added (% of GDP) in Industry in 2004 and the Value added (% of GDP) in Services in 2006?
Give a very brief answer. -29.35. What is the difference between the Value added (% of GDP) of Industry in 2004 and the Value added (% of GDP) of Agriculture in 2006?
Give a very brief answer. 31.31. What is the difference between the Value added (% of GDP) in Manufacturing in 2004 and the Value added (% of GDP) in Services in 2006?
Provide a succinct answer. -38.31. What is the difference between the Value added (% of GDP) in Manufacturing in 2004 and the Value added (% of GDP) in Agriculture in 2006?
Offer a very short reply. 22.35. What is the difference between the Value added (% of GDP) in Services in 2004 and the Value added (% of GDP) in Agriculture in 2006?
Provide a short and direct response. 61.37. What is the difference between the Value added (% of GDP) of Industry in 2004 and the Value added (% of GDP) of Manufacturing in 2007?
Your response must be concise. 8.31. What is the difference between the Value added (% of GDP) of Industry in 2004 and the Value added (% of GDP) of Services in 2007?
Ensure brevity in your answer.  -28.66. What is the difference between the Value added (% of GDP) of Industry in 2004 and the Value added (% of GDP) of Agriculture in 2007?
Your answer should be compact. 30.92. What is the difference between the Value added (% of GDP) of Manufacturing in 2004 and the Value added (% of GDP) of Services in 2007?
Offer a very short reply. -37.61. What is the difference between the Value added (% of GDP) in Manufacturing in 2004 and the Value added (% of GDP) in Agriculture in 2007?
Ensure brevity in your answer.  21.97. What is the difference between the Value added (% of GDP) of Services in 2004 and the Value added (% of GDP) of Agriculture in 2007?
Make the answer very short. 60.99. What is the difference between the Value added (% of GDP) of Industry in 2004 and the Value added (% of GDP) of Manufacturing in 2008?
Make the answer very short. 9.9. What is the difference between the Value added (% of GDP) of Industry in 2004 and the Value added (% of GDP) of Services in 2008?
Offer a very short reply. -30.23. What is the difference between the Value added (% of GDP) of Industry in 2004 and the Value added (% of GDP) of Agriculture in 2008?
Your answer should be compact. 31.14. What is the difference between the Value added (% of GDP) in Manufacturing in 2004 and the Value added (% of GDP) in Services in 2008?
Keep it short and to the point. -39.19. What is the difference between the Value added (% of GDP) of Manufacturing in 2004 and the Value added (% of GDP) of Agriculture in 2008?
Your response must be concise. 22.19. What is the difference between the Value added (% of GDP) of Services in 2004 and the Value added (% of GDP) of Agriculture in 2008?
Offer a very short reply. 61.21. What is the difference between the Value added (% of GDP) of Industry in 2004 and the Value added (% of GDP) of Manufacturing in 2009?
Your answer should be very brief. 14.48. What is the difference between the Value added (% of GDP) in Industry in 2004 and the Value added (% of GDP) in Services in 2009?
Your answer should be compact. -34.41. What is the difference between the Value added (% of GDP) of Industry in 2004 and the Value added (% of GDP) of Agriculture in 2009?
Offer a terse response. 31.06. What is the difference between the Value added (% of GDP) of Manufacturing in 2004 and the Value added (% of GDP) of Services in 2009?
Provide a succinct answer. -43.37. What is the difference between the Value added (% of GDP) in Manufacturing in 2004 and the Value added (% of GDP) in Agriculture in 2009?
Offer a terse response. 22.11. What is the difference between the Value added (% of GDP) in Services in 2004 and the Value added (% of GDP) in Agriculture in 2009?
Provide a succinct answer. 61.13. What is the difference between the Value added (% of GDP) of Industry in 2004 and the Value added (% of GDP) of Manufacturing in 2010?
Your answer should be very brief. 14.08. What is the difference between the Value added (% of GDP) of Industry in 2004 and the Value added (% of GDP) of Services in 2010?
Ensure brevity in your answer.  -33.69. What is the difference between the Value added (% of GDP) in Industry in 2004 and the Value added (% of GDP) in Agriculture in 2010?
Your answer should be very brief. 30.88. What is the difference between the Value added (% of GDP) of Manufacturing in 2004 and the Value added (% of GDP) of Services in 2010?
Your answer should be compact. -42.65. What is the difference between the Value added (% of GDP) of Manufacturing in 2004 and the Value added (% of GDP) of Agriculture in 2010?
Offer a very short reply. 21.92. What is the difference between the Value added (% of GDP) in Services in 2004 and the Value added (% of GDP) in Agriculture in 2010?
Your answer should be compact. 60.94. What is the difference between the Value added (% of GDP) of Industry in 2005 and the Value added (% of GDP) of Manufacturing in 2006?
Offer a very short reply. 8.48. What is the difference between the Value added (% of GDP) of Industry in 2005 and the Value added (% of GDP) of Services in 2006?
Ensure brevity in your answer.  -29.42. What is the difference between the Value added (% of GDP) in Industry in 2005 and the Value added (% of GDP) in Agriculture in 2006?
Ensure brevity in your answer.  31.24. What is the difference between the Value added (% of GDP) of Manufacturing in 2005 and the Value added (% of GDP) of Services in 2006?
Offer a very short reply. -38.63. What is the difference between the Value added (% of GDP) of Manufacturing in 2005 and the Value added (% of GDP) of Agriculture in 2006?
Offer a very short reply. 22.03. What is the difference between the Value added (% of GDP) in Services in 2005 and the Value added (% of GDP) in Agriculture in 2006?
Make the answer very short. 61.55. What is the difference between the Value added (% of GDP) of Industry in 2005 and the Value added (% of GDP) of Manufacturing in 2007?
Provide a succinct answer. 8.24. What is the difference between the Value added (% of GDP) of Industry in 2005 and the Value added (% of GDP) of Services in 2007?
Offer a very short reply. -28.72. What is the difference between the Value added (% of GDP) of Industry in 2005 and the Value added (% of GDP) of Agriculture in 2007?
Ensure brevity in your answer.  30.86. What is the difference between the Value added (% of GDP) of Manufacturing in 2005 and the Value added (% of GDP) of Services in 2007?
Provide a succinct answer. -37.94. What is the difference between the Value added (% of GDP) of Manufacturing in 2005 and the Value added (% of GDP) of Agriculture in 2007?
Offer a very short reply. 21.64. What is the difference between the Value added (% of GDP) in Services in 2005 and the Value added (% of GDP) in Agriculture in 2007?
Provide a succinct answer. 61.16. What is the difference between the Value added (% of GDP) of Industry in 2005 and the Value added (% of GDP) of Manufacturing in 2008?
Your answer should be very brief. 9.84. What is the difference between the Value added (% of GDP) in Industry in 2005 and the Value added (% of GDP) in Services in 2008?
Your response must be concise. -30.3. What is the difference between the Value added (% of GDP) in Industry in 2005 and the Value added (% of GDP) in Agriculture in 2008?
Provide a short and direct response. 31.08. What is the difference between the Value added (% of GDP) in Manufacturing in 2005 and the Value added (% of GDP) in Services in 2008?
Offer a very short reply. -39.51. What is the difference between the Value added (% of GDP) of Manufacturing in 2005 and the Value added (% of GDP) of Agriculture in 2008?
Ensure brevity in your answer.  21.86. What is the difference between the Value added (% of GDP) in Services in 2005 and the Value added (% of GDP) in Agriculture in 2008?
Your answer should be compact. 61.38. What is the difference between the Value added (% of GDP) in Industry in 2005 and the Value added (% of GDP) in Manufacturing in 2009?
Ensure brevity in your answer.  14.41. What is the difference between the Value added (% of GDP) in Industry in 2005 and the Value added (% of GDP) in Services in 2009?
Your answer should be compact. -34.48. What is the difference between the Value added (% of GDP) in Industry in 2005 and the Value added (% of GDP) in Agriculture in 2009?
Make the answer very short. 31. What is the difference between the Value added (% of GDP) of Manufacturing in 2005 and the Value added (% of GDP) of Services in 2009?
Your answer should be very brief. -43.69. What is the difference between the Value added (% of GDP) of Manufacturing in 2005 and the Value added (% of GDP) of Agriculture in 2009?
Offer a terse response. 21.78. What is the difference between the Value added (% of GDP) in Services in 2005 and the Value added (% of GDP) in Agriculture in 2009?
Make the answer very short. 61.3. What is the difference between the Value added (% of GDP) of Industry in 2005 and the Value added (% of GDP) of Manufacturing in 2010?
Provide a short and direct response. 14.01. What is the difference between the Value added (% of GDP) in Industry in 2005 and the Value added (% of GDP) in Services in 2010?
Ensure brevity in your answer.  -33.76. What is the difference between the Value added (% of GDP) of Industry in 2005 and the Value added (% of GDP) of Agriculture in 2010?
Your response must be concise. 30.81. What is the difference between the Value added (% of GDP) in Manufacturing in 2005 and the Value added (% of GDP) in Services in 2010?
Provide a short and direct response. -42.97. What is the difference between the Value added (% of GDP) in Manufacturing in 2005 and the Value added (% of GDP) in Agriculture in 2010?
Give a very brief answer. 21.6. What is the difference between the Value added (% of GDP) of Services in 2005 and the Value added (% of GDP) of Agriculture in 2010?
Give a very brief answer. 61.12. What is the difference between the Value added (% of GDP) of Industry in 2006 and the Value added (% of GDP) of Manufacturing in 2007?
Ensure brevity in your answer.  9.45. What is the difference between the Value added (% of GDP) in Industry in 2006 and the Value added (% of GDP) in Services in 2007?
Provide a succinct answer. -27.52. What is the difference between the Value added (% of GDP) in Industry in 2006 and the Value added (% of GDP) in Agriculture in 2007?
Provide a succinct answer. 32.06. What is the difference between the Value added (% of GDP) of Manufacturing in 2006 and the Value added (% of GDP) of Services in 2007?
Keep it short and to the point. -37.2. What is the difference between the Value added (% of GDP) of Manufacturing in 2006 and the Value added (% of GDP) of Agriculture in 2007?
Ensure brevity in your answer.  22.38. What is the difference between the Value added (% of GDP) of Services in 2006 and the Value added (% of GDP) of Agriculture in 2007?
Provide a short and direct response. 60.27. What is the difference between the Value added (% of GDP) in Industry in 2006 and the Value added (% of GDP) in Manufacturing in 2008?
Offer a terse response. 11.04. What is the difference between the Value added (% of GDP) of Industry in 2006 and the Value added (% of GDP) of Services in 2008?
Your response must be concise. -29.1. What is the difference between the Value added (% of GDP) of Industry in 2006 and the Value added (% of GDP) of Agriculture in 2008?
Offer a terse response. 32.28. What is the difference between the Value added (% of GDP) in Manufacturing in 2006 and the Value added (% of GDP) in Services in 2008?
Provide a succinct answer. -38.78. What is the difference between the Value added (% of GDP) of Manufacturing in 2006 and the Value added (% of GDP) of Agriculture in 2008?
Offer a very short reply. 22.6. What is the difference between the Value added (% of GDP) in Services in 2006 and the Value added (% of GDP) in Agriculture in 2008?
Give a very brief answer. 60.49. What is the difference between the Value added (% of GDP) of Industry in 2006 and the Value added (% of GDP) of Manufacturing in 2009?
Give a very brief answer. 15.61. What is the difference between the Value added (% of GDP) of Industry in 2006 and the Value added (% of GDP) of Services in 2009?
Your response must be concise. -33.27. What is the difference between the Value added (% of GDP) in Industry in 2006 and the Value added (% of GDP) in Agriculture in 2009?
Your answer should be compact. 32.2. What is the difference between the Value added (% of GDP) in Manufacturing in 2006 and the Value added (% of GDP) in Services in 2009?
Your answer should be very brief. -42.96. What is the difference between the Value added (% of GDP) of Manufacturing in 2006 and the Value added (% of GDP) of Agriculture in 2009?
Provide a succinct answer. 22.52. What is the difference between the Value added (% of GDP) of Services in 2006 and the Value added (% of GDP) of Agriculture in 2009?
Provide a short and direct response. 60.41. What is the difference between the Value added (% of GDP) of Industry in 2006 and the Value added (% of GDP) of Manufacturing in 2010?
Offer a terse response. 15.22. What is the difference between the Value added (% of GDP) of Industry in 2006 and the Value added (% of GDP) of Services in 2010?
Make the answer very short. -32.55. What is the difference between the Value added (% of GDP) of Industry in 2006 and the Value added (% of GDP) of Agriculture in 2010?
Give a very brief answer. 32.01. What is the difference between the Value added (% of GDP) in Manufacturing in 2006 and the Value added (% of GDP) in Services in 2010?
Provide a succinct answer. -42.23. What is the difference between the Value added (% of GDP) of Manufacturing in 2006 and the Value added (% of GDP) of Agriculture in 2010?
Ensure brevity in your answer.  22.33. What is the difference between the Value added (% of GDP) in Services in 2006 and the Value added (% of GDP) in Agriculture in 2010?
Your answer should be compact. 60.23. What is the difference between the Value added (% of GDP) of Industry in 2007 and the Value added (% of GDP) of Manufacturing in 2008?
Your response must be concise. 11.35. What is the difference between the Value added (% of GDP) in Industry in 2007 and the Value added (% of GDP) in Services in 2008?
Provide a succinct answer. -28.79. What is the difference between the Value added (% of GDP) of Industry in 2007 and the Value added (% of GDP) of Agriculture in 2008?
Your response must be concise. 32.59. What is the difference between the Value added (% of GDP) in Manufacturing in 2007 and the Value added (% of GDP) in Services in 2008?
Offer a terse response. -38.54. What is the difference between the Value added (% of GDP) of Manufacturing in 2007 and the Value added (% of GDP) of Agriculture in 2008?
Offer a terse response. 22.83. What is the difference between the Value added (% of GDP) in Services in 2007 and the Value added (% of GDP) in Agriculture in 2008?
Your answer should be compact. 59.8. What is the difference between the Value added (% of GDP) in Industry in 2007 and the Value added (% of GDP) in Manufacturing in 2009?
Provide a succinct answer. 15.92. What is the difference between the Value added (% of GDP) of Industry in 2007 and the Value added (% of GDP) of Services in 2009?
Ensure brevity in your answer.  -32.96. What is the difference between the Value added (% of GDP) of Industry in 2007 and the Value added (% of GDP) of Agriculture in 2009?
Make the answer very short. 32.51. What is the difference between the Value added (% of GDP) in Manufacturing in 2007 and the Value added (% of GDP) in Services in 2009?
Offer a very short reply. -42.72. What is the difference between the Value added (% of GDP) in Manufacturing in 2007 and the Value added (% of GDP) in Agriculture in 2009?
Offer a very short reply. 22.75. What is the difference between the Value added (% of GDP) of Services in 2007 and the Value added (% of GDP) of Agriculture in 2009?
Offer a very short reply. 59.72. What is the difference between the Value added (% of GDP) in Industry in 2007 and the Value added (% of GDP) in Manufacturing in 2010?
Give a very brief answer. 15.53. What is the difference between the Value added (% of GDP) of Industry in 2007 and the Value added (% of GDP) of Services in 2010?
Your answer should be very brief. -32.24. What is the difference between the Value added (% of GDP) in Industry in 2007 and the Value added (% of GDP) in Agriculture in 2010?
Make the answer very short. 32.32. What is the difference between the Value added (% of GDP) in Manufacturing in 2007 and the Value added (% of GDP) in Services in 2010?
Offer a very short reply. -42. What is the difference between the Value added (% of GDP) in Manufacturing in 2007 and the Value added (% of GDP) in Agriculture in 2010?
Your answer should be very brief. 22.57. What is the difference between the Value added (% of GDP) of Services in 2007 and the Value added (% of GDP) of Agriculture in 2010?
Your answer should be very brief. 59.53. What is the difference between the Value added (% of GDP) in Industry in 2008 and the Value added (% of GDP) in Manufacturing in 2009?
Your response must be concise. 14.57. What is the difference between the Value added (% of GDP) in Industry in 2008 and the Value added (% of GDP) in Services in 2009?
Provide a succinct answer. -34.32. What is the difference between the Value added (% of GDP) in Industry in 2008 and the Value added (% of GDP) in Agriculture in 2009?
Give a very brief answer. 31.15. What is the difference between the Value added (% of GDP) of Manufacturing in 2008 and the Value added (% of GDP) of Services in 2009?
Your answer should be compact. -44.32. What is the difference between the Value added (% of GDP) in Manufacturing in 2008 and the Value added (% of GDP) in Agriculture in 2009?
Give a very brief answer. 21.16. What is the difference between the Value added (% of GDP) of Services in 2008 and the Value added (% of GDP) of Agriculture in 2009?
Keep it short and to the point. 61.3. What is the difference between the Value added (% of GDP) in Industry in 2008 and the Value added (% of GDP) in Manufacturing in 2010?
Your answer should be very brief. 14.17. What is the difference between the Value added (% of GDP) of Industry in 2008 and the Value added (% of GDP) of Services in 2010?
Provide a succinct answer. -33.6. What is the difference between the Value added (% of GDP) of Industry in 2008 and the Value added (% of GDP) of Agriculture in 2010?
Provide a short and direct response. 30.97. What is the difference between the Value added (% of GDP) in Manufacturing in 2008 and the Value added (% of GDP) in Services in 2010?
Offer a very short reply. -43.59. What is the difference between the Value added (% of GDP) in Manufacturing in 2008 and the Value added (% of GDP) in Agriculture in 2010?
Your response must be concise. 20.97. What is the difference between the Value added (% of GDP) of Services in 2008 and the Value added (% of GDP) of Agriculture in 2010?
Ensure brevity in your answer.  61.11. What is the difference between the Value added (% of GDP) in Industry in 2009 and the Value added (% of GDP) in Manufacturing in 2010?
Offer a terse response. 9.91. What is the difference between the Value added (% of GDP) of Industry in 2009 and the Value added (% of GDP) of Services in 2010?
Your answer should be compact. -37.86. What is the difference between the Value added (% of GDP) in Industry in 2009 and the Value added (% of GDP) in Agriculture in 2010?
Provide a succinct answer. 26.71. What is the difference between the Value added (% of GDP) in Manufacturing in 2009 and the Value added (% of GDP) in Services in 2010?
Make the answer very short. -48.17. What is the difference between the Value added (% of GDP) of Manufacturing in 2009 and the Value added (% of GDP) of Agriculture in 2010?
Give a very brief answer. 16.4. What is the difference between the Value added (% of GDP) of Services in 2009 and the Value added (% of GDP) of Agriculture in 2010?
Provide a succinct answer. 65.29. What is the average Value added (% of GDP) in Industry per year?
Offer a very short reply. 33.15. What is the average Value added (% of GDP) in Manufacturing per year?
Your answer should be very brief. 23.67. What is the average Value added (% of GDP) of Services per year?
Offer a terse response. 64.19. What is the average Value added (% of GDP) of Agriculture per year?
Ensure brevity in your answer.  2.67. In the year 2002, what is the difference between the Value added (% of GDP) in Industry and Value added (% of GDP) in Manufacturing?
Ensure brevity in your answer.  8.27. In the year 2002, what is the difference between the Value added (% of GDP) of Industry and Value added (% of GDP) of Services?
Provide a succinct answer. -28.18. In the year 2002, what is the difference between the Value added (% of GDP) in Industry and Value added (% of GDP) in Agriculture?
Ensure brevity in your answer.  31.33. In the year 2002, what is the difference between the Value added (% of GDP) in Manufacturing and Value added (% of GDP) in Services?
Offer a very short reply. -36.45. In the year 2002, what is the difference between the Value added (% of GDP) in Manufacturing and Value added (% of GDP) in Agriculture?
Keep it short and to the point. 23.06. In the year 2002, what is the difference between the Value added (% of GDP) of Services and Value added (% of GDP) of Agriculture?
Your answer should be very brief. 59.51. In the year 2003, what is the difference between the Value added (% of GDP) in Industry and Value added (% of GDP) in Manufacturing?
Make the answer very short. 8.7. In the year 2003, what is the difference between the Value added (% of GDP) in Industry and Value added (% of GDP) in Services?
Your response must be concise. -29.33. In the year 2003, what is the difference between the Value added (% of GDP) in Industry and Value added (% of GDP) in Agriculture?
Ensure brevity in your answer.  30.97. In the year 2003, what is the difference between the Value added (% of GDP) of Manufacturing and Value added (% of GDP) of Services?
Your answer should be compact. -38.02. In the year 2003, what is the difference between the Value added (% of GDP) of Manufacturing and Value added (% of GDP) of Agriculture?
Give a very brief answer. 22.27. In the year 2003, what is the difference between the Value added (% of GDP) of Services and Value added (% of GDP) of Agriculture?
Your response must be concise. 60.3. In the year 2004, what is the difference between the Value added (% of GDP) of Industry and Value added (% of GDP) of Manufacturing?
Your answer should be compact. 8.96. In the year 2004, what is the difference between the Value added (% of GDP) in Industry and Value added (% of GDP) in Services?
Provide a short and direct response. -30.07. In the year 2004, what is the difference between the Value added (% of GDP) of Industry and Value added (% of GDP) of Agriculture?
Provide a short and direct response. 30.88. In the year 2004, what is the difference between the Value added (% of GDP) in Manufacturing and Value added (% of GDP) in Services?
Keep it short and to the point. -39.02. In the year 2004, what is the difference between the Value added (% of GDP) in Manufacturing and Value added (% of GDP) in Agriculture?
Offer a terse response. 21.93. In the year 2004, what is the difference between the Value added (% of GDP) of Services and Value added (% of GDP) of Agriculture?
Your response must be concise. 60.95. In the year 2005, what is the difference between the Value added (% of GDP) in Industry and Value added (% of GDP) in Manufacturing?
Ensure brevity in your answer.  9.21. In the year 2005, what is the difference between the Value added (% of GDP) in Industry and Value added (% of GDP) in Services?
Your response must be concise. -30.31. In the year 2005, what is the difference between the Value added (% of GDP) in Industry and Value added (% of GDP) in Agriculture?
Your answer should be compact. 30.93. In the year 2005, what is the difference between the Value added (% of GDP) of Manufacturing and Value added (% of GDP) of Services?
Ensure brevity in your answer.  -39.52. In the year 2005, what is the difference between the Value added (% of GDP) in Manufacturing and Value added (% of GDP) in Agriculture?
Keep it short and to the point. 21.71. In the year 2005, what is the difference between the Value added (% of GDP) of Services and Value added (% of GDP) of Agriculture?
Ensure brevity in your answer.  61.24. In the year 2006, what is the difference between the Value added (% of GDP) of Industry and Value added (% of GDP) of Manufacturing?
Ensure brevity in your answer.  9.68. In the year 2006, what is the difference between the Value added (% of GDP) in Industry and Value added (% of GDP) in Services?
Your answer should be very brief. -28.21. In the year 2006, what is the difference between the Value added (% of GDP) in Industry and Value added (% of GDP) in Agriculture?
Provide a short and direct response. 32.45. In the year 2006, what is the difference between the Value added (% of GDP) in Manufacturing and Value added (% of GDP) in Services?
Provide a succinct answer. -37.9. In the year 2006, what is the difference between the Value added (% of GDP) in Manufacturing and Value added (% of GDP) in Agriculture?
Provide a short and direct response. 22.76. In the year 2006, what is the difference between the Value added (% of GDP) of Services and Value added (% of GDP) of Agriculture?
Keep it short and to the point. 60.66. In the year 2007, what is the difference between the Value added (% of GDP) in Industry and Value added (% of GDP) in Manufacturing?
Keep it short and to the point. 9.76. In the year 2007, what is the difference between the Value added (% of GDP) of Industry and Value added (% of GDP) of Services?
Your answer should be compact. -27.21. In the year 2007, what is the difference between the Value added (% of GDP) of Industry and Value added (% of GDP) of Agriculture?
Offer a terse response. 32.37. In the year 2007, what is the difference between the Value added (% of GDP) in Manufacturing and Value added (% of GDP) in Services?
Your answer should be compact. -36.97. In the year 2007, what is the difference between the Value added (% of GDP) of Manufacturing and Value added (% of GDP) of Agriculture?
Make the answer very short. 22.61. In the year 2007, what is the difference between the Value added (% of GDP) in Services and Value added (% of GDP) in Agriculture?
Keep it short and to the point. 59.58. In the year 2008, what is the difference between the Value added (% of GDP) of Industry and Value added (% of GDP) of Manufacturing?
Keep it short and to the point. 9.99. In the year 2008, what is the difference between the Value added (% of GDP) of Industry and Value added (% of GDP) of Services?
Offer a terse response. -30.14. In the year 2008, what is the difference between the Value added (% of GDP) of Industry and Value added (% of GDP) of Agriculture?
Offer a very short reply. 31.23. In the year 2008, what is the difference between the Value added (% of GDP) of Manufacturing and Value added (% of GDP) of Services?
Your answer should be compact. -40.14. In the year 2008, what is the difference between the Value added (% of GDP) in Manufacturing and Value added (% of GDP) in Agriculture?
Make the answer very short. 21.24. In the year 2008, what is the difference between the Value added (% of GDP) in Services and Value added (% of GDP) in Agriculture?
Provide a short and direct response. 61.38. In the year 2009, what is the difference between the Value added (% of GDP) in Industry and Value added (% of GDP) in Manufacturing?
Ensure brevity in your answer.  10.31. In the year 2009, what is the difference between the Value added (% of GDP) of Industry and Value added (% of GDP) of Services?
Your answer should be compact. -38.58. In the year 2009, what is the difference between the Value added (% of GDP) in Industry and Value added (% of GDP) in Agriculture?
Your response must be concise. 26.9. In the year 2009, what is the difference between the Value added (% of GDP) in Manufacturing and Value added (% of GDP) in Services?
Provide a succinct answer. -48.89. In the year 2009, what is the difference between the Value added (% of GDP) of Manufacturing and Value added (% of GDP) of Agriculture?
Make the answer very short. 16.59. In the year 2009, what is the difference between the Value added (% of GDP) in Services and Value added (% of GDP) in Agriculture?
Your response must be concise. 65.47. In the year 2010, what is the difference between the Value added (% of GDP) of Industry and Value added (% of GDP) of Manufacturing?
Provide a short and direct response. 10.45. In the year 2010, what is the difference between the Value added (% of GDP) of Industry and Value added (% of GDP) of Services?
Offer a terse response. -37.32. In the year 2010, what is the difference between the Value added (% of GDP) in Industry and Value added (% of GDP) in Agriculture?
Offer a terse response. 27.24. In the year 2010, what is the difference between the Value added (% of GDP) of Manufacturing and Value added (% of GDP) of Services?
Make the answer very short. -47.77. In the year 2010, what is the difference between the Value added (% of GDP) of Manufacturing and Value added (% of GDP) of Agriculture?
Ensure brevity in your answer.  16.8. In the year 2010, what is the difference between the Value added (% of GDP) of Services and Value added (% of GDP) of Agriculture?
Your answer should be compact. 64.56. What is the ratio of the Value added (% of GDP) in Industry in 2002 to that in 2003?
Make the answer very short. 1.01. What is the ratio of the Value added (% of GDP) of Manufacturing in 2002 to that in 2003?
Your answer should be very brief. 1.04. What is the ratio of the Value added (% of GDP) in Services in 2002 to that in 2003?
Keep it short and to the point. 0.99. What is the ratio of the Value added (% of GDP) in Agriculture in 2002 to that in 2003?
Provide a short and direct response. 1.05. What is the ratio of the Value added (% of GDP) of Industry in 2002 to that in 2004?
Offer a terse response. 1.02. What is the ratio of the Value added (% of GDP) in Manufacturing in 2002 to that in 2004?
Your response must be concise. 1.06. What is the ratio of the Value added (% of GDP) of Services in 2002 to that in 2004?
Provide a short and direct response. 0.98. What is the ratio of the Value added (% of GDP) of Agriculture in 2002 to that in 2004?
Keep it short and to the point. 1.12. What is the ratio of the Value added (% of GDP) of Industry in 2002 to that in 2005?
Provide a short and direct response. 1.03. What is the ratio of the Value added (% of GDP) in Manufacturing in 2002 to that in 2005?
Keep it short and to the point. 1.07. What is the ratio of the Value added (% of GDP) of Services in 2002 to that in 2005?
Make the answer very short. 0.98. What is the ratio of the Value added (% of GDP) in Agriculture in 2002 to that in 2005?
Keep it short and to the point. 1.17. What is the ratio of the Value added (% of GDP) in Manufacturing in 2002 to that in 2006?
Offer a very short reply. 1.04. What is the ratio of the Value added (% of GDP) in Services in 2002 to that in 2006?
Your response must be concise. 0.99. What is the ratio of the Value added (% of GDP) of Agriculture in 2002 to that in 2006?
Keep it short and to the point. 1.33. What is the ratio of the Value added (% of GDP) of Industry in 2002 to that in 2007?
Offer a terse response. 0.98. What is the ratio of the Value added (% of GDP) in Manufacturing in 2002 to that in 2007?
Keep it short and to the point. 1.03. What is the ratio of the Value added (% of GDP) in Agriculture in 2002 to that in 2007?
Offer a very short reply. 1.14. What is the ratio of the Value added (% of GDP) of Industry in 2002 to that in 2008?
Offer a terse response. 1.02. What is the ratio of the Value added (% of GDP) in Manufacturing in 2002 to that in 2008?
Provide a succinct answer. 1.1. What is the ratio of the Value added (% of GDP) of Services in 2002 to that in 2008?
Offer a very short reply. 0.98. What is the ratio of the Value added (% of GDP) in Agriculture in 2002 to that in 2008?
Your answer should be very brief. 1.24. What is the ratio of the Value added (% of GDP) of Industry in 2002 to that in 2009?
Make the answer very short. 1.17. What is the ratio of the Value added (% of GDP) of Manufacturing in 2002 to that in 2009?
Make the answer very short. 1.37. What is the ratio of the Value added (% of GDP) of Services in 2002 to that in 2009?
Keep it short and to the point. 0.92. What is the ratio of the Value added (% of GDP) of Agriculture in 2002 to that in 2009?
Offer a very short reply. 1.2. What is the ratio of the Value added (% of GDP) of Industry in 2002 to that in 2010?
Your answer should be compact. 1.15. What is the ratio of the Value added (% of GDP) of Manufacturing in 2002 to that in 2010?
Give a very brief answer. 1.34. What is the ratio of the Value added (% of GDP) in Services in 2002 to that in 2010?
Provide a succinct answer. 0.93. What is the ratio of the Value added (% of GDP) of Agriculture in 2002 to that in 2010?
Your answer should be compact. 1.12. What is the ratio of the Value added (% of GDP) in Industry in 2003 to that in 2004?
Provide a short and direct response. 1.01. What is the ratio of the Value added (% of GDP) in Manufacturing in 2003 to that in 2004?
Provide a succinct answer. 1.02. What is the ratio of the Value added (% of GDP) of Services in 2003 to that in 2004?
Offer a very short reply. 0.99. What is the ratio of the Value added (% of GDP) of Agriculture in 2003 to that in 2004?
Give a very brief answer. 1.07. What is the ratio of the Value added (% of GDP) in Industry in 2003 to that in 2005?
Your answer should be compact. 1.01. What is the ratio of the Value added (% of GDP) of Manufacturing in 2003 to that in 2005?
Offer a very short reply. 1.04. What is the ratio of the Value added (% of GDP) of Agriculture in 2003 to that in 2005?
Give a very brief answer. 1.11. What is the ratio of the Value added (% of GDP) of Industry in 2003 to that in 2006?
Your answer should be compact. 0.98. What is the ratio of the Value added (% of GDP) in Agriculture in 2003 to that in 2006?
Give a very brief answer. 1.27. What is the ratio of the Value added (% of GDP) of Industry in 2003 to that in 2007?
Provide a succinct answer. 0.97. What is the ratio of the Value added (% of GDP) of Services in 2003 to that in 2007?
Offer a very short reply. 1.02. What is the ratio of the Value added (% of GDP) of Agriculture in 2003 to that in 2007?
Your answer should be very brief. 1.08. What is the ratio of the Value added (% of GDP) of Manufacturing in 2003 to that in 2008?
Offer a terse response. 1.06. What is the ratio of the Value added (% of GDP) of Agriculture in 2003 to that in 2008?
Offer a terse response. 1.18. What is the ratio of the Value added (% of GDP) in Industry in 2003 to that in 2009?
Give a very brief answer. 1.15. What is the ratio of the Value added (% of GDP) of Manufacturing in 2003 to that in 2009?
Keep it short and to the point. 1.32. What is the ratio of the Value added (% of GDP) in Services in 2003 to that in 2009?
Offer a terse response. 0.93. What is the ratio of the Value added (% of GDP) in Agriculture in 2003 to that in 2009?
Make the answer very short. 1.14. What is the ratio of the Value added (% of GDP) in Industry in 2003 to that in 2010?
Your answer should be compact. 1.13. What is the ratio of the Value added (% of GDP) in Manufacturing in 2003 to that in 2010?
Offer a very short reply. 1.29. What is the ratio of the Value added (% of GDP) of Services in 2003 to that in 2010?
Keep it short and to the point. 0.94. What is the ratio of the Value added (% of GDP) in Agriculture in 2003 to that in 2010?
Keep it short and to the point. 1.07. What is the ratio of the Value added (% of GDP) in Industry in 2004 to that in 2005?
Your answer should be very brief. 1. What is the ratio of the Value added (% of GDP) in Manufacturing in 2004 to that in 2005?
Provide a short and direct response. 1.01. What is the ratio of the Value added (% of GDP) of Services in 2004 to that in 2005?
Make the answer very short. 1. What is the ratio of the Value added (% of GDP) of Agriculture in 2004 to that in 2005?
Provide a succinct answer. 1.04. What is the ratio of the Value added (% of GDP) in Industry in 2004 to that in 2006?
Your answer should be very brief. 0.97. What is the ratio of the Value added (% of GDP) of Manufacturing in 2004 to that in 2006?
Keep it short and to the point. 0.98. What is the ratio of the Value added (% of GDP) of Services in 2004 to that in 2006?
Keep it short and to the point. 1.01. What is the ratio of the Value added (% of GDP) of Agriculture in 2004 to that in 2006?
Provide a succinct answer. 1.18. What is the ratio of the Value added (% of GDP) in Industry in 2004 to that in 2007?
Ensure brevity in your answer.  0.96. What is the ratio of the Value added (% of GDP) of Manufacturing in 2004 to that in 2007?
Your response must be concise. 0.97. What is the ratio of the Value added (% of GDP) in Services in 2004 to that in 2007?
Ensure brevity in your answer.  1.02. What is the ratio of the Value added (% of GDP) in Agriculture in 2004 to that in 2007?
Your answer should be compact. 1.01. What is the ratio of the Value added (% of GDP) of Industry in 2004 to that in 2008?
Keep it short and to the point. 1. What is the ratio of the Value added (% of GDP) of Agriculture in 2004 to that in 2008?
Your response must be concise. 1.11. What is the ratio of the Value added (% of GDP) of Industry in 2004 to that in 2009?
Give a very brief answer. 1.14. What is the ratio of the Value added (% of GDP) of Manufacturing in 2004 to that in 2009?
Give a very brief answer. 1.29. What is the ratio of the Value added (% of GDP) of Services in 2004 to that in 2009?
Ensure brevity in your answer.  0.94. What is the ratio of the Value added (% of GDP) of Agriculture in 2004 to that in 2009?
Offer a terse response. 1.07. What is the ratio of the Value added (% of GDP) of Industry in 2004 to that in 2010?
Offer a very short reply. 1.12. What is the ratio of the Value added (% of GDP) in Manufacturing in 2004 to that in 2010?
Your response must be concise. 1.26. What is the ratio of the Value added (% of GDP) of Services in 2004 to that in 2010?
Your answer should be very brief. 0.95. What is the ratio of the Value added (% of GDP) in Industry in 2005 to that in 2006?
Ensure brevity in your answer.  0.97. What is the ratio of the Value added (% of GDP) of Manufacturing in 2005 to that in 2006?
Offer a terse response. 0.97. What is the ratio of the Value added (% of GDP) of Services in 2005 to that in 2006?
Keep it short and to the point. 1.01. What is the ratio of the Value added (% of GDP) in Agriculture in 2005 to that in 2006?
Your answer should be very brief. 1.14. What is the ratio of the Value added (% of GDP) of Industry in 2005 to that in 2007?
Offer a very short reply. 0.96. What is the ratio of the Value added (% of GDP) in Manufacturing in 2005 to that in 2007?
Keep it short and to the point. 0.96. What is the ratio of the Value added (% of GDP) in Services in 2005 to that in 2007?
Keep it short and to the point. 1.03. What is the ratio of the Value added (% of GDP) of Agriculture in 2005 to that in 2007?
Offer a terse response. 0.97. What is the ratio of the Value added (% of GDP) in Manufacturing in 2005 to that in 2008?
Offer a terse response. 1.03. What is the ratio of the Value added (% of GDP) in Agriculture in 2005 to that in 2008?
Keep it short and to the point. 1.06. What is the ratio of the Value added (% of GDP) in Industry in 2005 to that in 2009?
Provide a succinct answer. 1.14. What is the ratio of the Value added (% of GDP) in Manufacturing in 2005 to that in 2009?
Make the answer very short. 1.27. What is the ratio of the Value added (% of GDP) in Services in 2005 to that in 2009?
Give a very brief answer. 0.94. What is the ratio of the Value added (% of GDP) of Industry in 2005 to that in 2010?
Offer a very short reply. 1.12. What is the ratio of the Value added (% of GDP) of Manufacturing in 2005 to that in 2010?
Keep it short and to the point. 1.25. What is the ratio of the Value added (% of GDP) in Services in 2005 to that in 2010?
Give a very brief answer. 0.95. What is the ratio of the Value added (% of GDP) of Agriculture in 2005 to that in 2010?
Provide a succinct answer. 0.96. What is the ratio of the Value added (% of GDP) in Manufacturing in 2006 to that in 2007?
Keep it short and to the point. 0.99. What is the ratio of the Value added (% of GDP) in Services in 2006 to that in 2007?
Your response must be concise. 1.01. What is the ratio of the Value added (% of GDP) of Agriculture in 2006 to that in 2007?
Your answer should be compact. 0.86. What is the ratio of the Value added (% of GDP) in Industry in 2006 to that in 2008?
Offer a terse response. 1.03. What is the ratio of the Value added (% of GDP) of Manufacturing in 2006 to that in 2008?
Your answer should be very brief. 1.06. What is the ratio of the Value added (% of GDP) in Services in 2006 to that in 2008?
Your answer should be very brief. 0.99. What is the ratio of the Value added (% of GDP) of Industry in 2006 to that in 2009?
Offer a very short reply. 1.18. What is the ratio of the Value added (% of GDP) in Manufacturing in 2006 to that in 2009?
Your answer should be compact. 1.31. What is the ratio of the Value added (% of GDP) in Services in 2006 to that in 2009?
Offer a terse response. 0.93. What is the ratio of the Value added (% of GDP) in Agriculture in 2006 to that in 2009?
Your answer should be very brief. 0.9. What is the ratio of the Value added (% of GDP) in Industry in 2006 to that in 2010?
Make the answer very short. 1.16. What is the ratio of the Value added (% of GDP) of Manufacturing in 2006 to that in 2010?
Give a very brief answer. 1.28. What is the ratio of the Value added (% of GDP) in Services in 2006 to that in 2010?
Ensure brevity in your answer.  0.94. What is the ratio of the Value added (% of GDP) in Agriculture in 2006 to that in 2010?
Your answer should be very brief. 0.84. What is the ratio of the Value added (% of GDP) in Industry in 2007 to that in 2008?
Provide a succinct answer. 1.04. What is the ratio of the Value added (% of GDP) of Manufacturing in 2007 to that in 2008?
Offer a very short reply. 1.07. What is the ratio of the Value added (% of GDP) of Services in 2007 to that in 2008?
Offer a very short reply. 0.98. What is the ratio of the Value added (% of GDP) of Agriculture in 2007 to that in 2008?
Offer a terse response. 1.09. What is the ratio of the Value added (% of GDP) in Industry in 2007 to that in 2009?
Offer a terse response. 1.19. What is the ratio of the Value added (% of GDP) in Manufacturing in 2007 to that in 2009?
Your response must be concise. 1.32. What is the ratio of the Value added (% of GDP) in Services in 2007 to that in 2009?
Provide a short and direct response. 0.92. What is the ratio of the Value added (% of GDP) in Agriculture in 2007 to that in 2009?
Keep it short and to the point. 1.05. What is the ratio of the Value added (% of GDP) of Industry in 2007 to that in 2010?
Your response must be concise. 1.17. What is the ratio of the Value added (% of GDP) of Manufacturing in 2007 to that in 2010?
Offer a terse response. 1.3. What is the ratio of the Value added (% of GDP) of Services in 2007 to that in 2010?
Give a very brief answer. 0.93. What is the ratio of the Value added (% of GDP) of Agriculture in 2007 to that in 2010?
Your answer should be compact. 0.98. What is the ratio of the Value added (% of GDP) in Industry in 2008 to that in 2009?
Offer a very short reply. 1.14. What is the ratio of the Value added (% of GDP) in Manufacturing in 2008 to that in 2009?
Make the answer very short. 1.24. What is the ratio of the Value added (% of GDP) of Services in 2008 to that in 2009?
Offer a terse response. 0.94. What is the ratio of the Value added (% of GDP) of Agriculture in 2008 to that in 2009?
Offer a very short reply. 0.97. What is the ratio of the Value added (% of GDP) of Industry in 2008 to that in 2010?
Make the answer very short. 1.12. What is the ratio of the Value added (% of GDP) in Manufacturing in 2008 to that in 2010?
Make the answer very short. 1.21. What is the ratio of the Value added (% of GDP) in Services in 2008 to that in 2010?
Make the answer very short. 0.95. What is the ratio of the Value added (% of GDP) of Agriculture in 2008 to that in 2010?
Offer a very short reply. 0.9. What is the ratio of the Value added (% of GDP) in Industry in 2009 to that in 2010?
Offer a terse response. 0.98. What is the ratio of the Value added (% of GDP) of Manufacturing in 2009 to that in 2010?
Your answer should be compact. 0.98. What is the ratio of the Value added (% of GDP) in Services in 2009 to that in 2010?
Ensure brevity in your answer.  1.01. What is the ratio of the Value added (% of GDP) in Agriculture in 2009 to that in 2010?
Make the answer very short. 0.93. What is the difference between the highest and the second highest Value added (% of GDP) of Industry?
Offer a very short reply. 0.31. What is the difference between the highest and the second highest Value added (% of GDP) of Manufacturing?
Your answer should be very brief. 0.82. What is the difference between the highest and the second highest Value added (% of GDP) in Services?
Make the answer very short. 0.72. What is the difference between the highest and the second highest Value added (% of GDP) of Agriculture?
Offer a very short reply. 0.14. What is the difference between the highest and the lowest Value added (% of GDP) in Industry?
Your answer should be compact. 5.61. What is the difference between the highest and the lowest Value added (% of GDP) of Manufacturing?
Offer a very short reply. 6.99. What is the difference between the highest and the lowest Value added (% of GDP) of Services?
Your answer should be compact. 5.75. What is the difference between the highest and the lowest Value added (% of GDP) of Agriculture?
Make the answer very short. 0.75. 